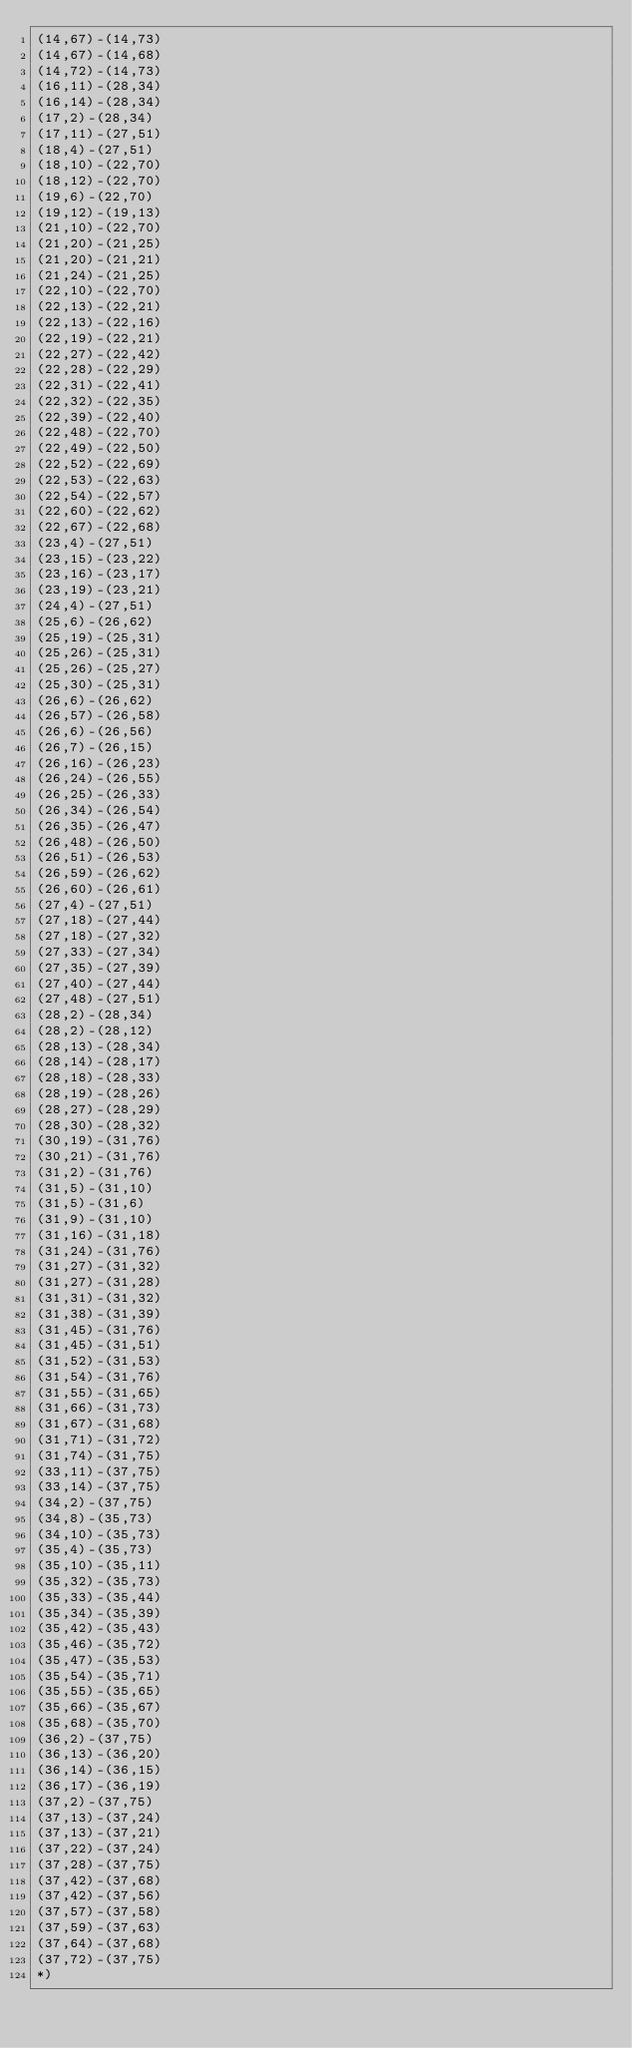<code> <loc_0><loc_0><loc_500><loc_500><_OCaml_>(14,67)-(14,73)
(14,67)-(14,68)
(14,72)-(14,73)
(16,11)-(28,34)
(16,14)-(28,34)
(17,2)-(28,34)
(17,11)-(27,51)
(18,4)-(27,51)
(18,10)-(22,70)
(18,12)-(22,70)
(19,6)-(22,70)
(19,12)-(19,13)
(21,10)-(22,70)
(21,20)-(21,25)
(21,20)-(21,21)
(21,24)-(21,25)
(22,10)-(22,70)
(22,13)-(22,21)
(22,13)-(22,16)
(22,19)-(22,21)
(22,27)-(22,42)
(22,28)-(22,29)
(22,31)-(22,41)
(22,32)-(22,35)
(22,39)-(22,40)
(22,48)-(22,70)
(22,49)-(22,50)
(22,52)-(22,69)
(22,53)-(22,63)
(22,54)-(22,57)
(22,60)-(22,62)
(22,67)-(22,68)
(23,4)-(27,51)
(23,15)-(23,22)
(23,16)-(23,17)
(23,19)-(23,21)
(24,4)-(27,51)
(25,6)-(26,62)
(25,19)-(25,31)
(25,26)-(25,31)
(25,26)-(25,27)
(25,30)-(25,31)
(26,6)-(26,62)
(26,57)-(26,58)
(26,6)-(26,56)
(26,7)-(26,15)
(26,16)-(26,23)
(26,24)-(26,55)
(26,25)-(26,33)
(26,34)-(26,54)
(26,35)-(26,47)
(26,48)-(26,50)
(26,51)-(26,53)
(26,59)-(26,62)
(26,60)-(26,61)
(27,4)-(27,51)
(27,18)-(27,44)
(27,18)-(27,32)
(27,33)-(27,34)
(27,35)-(27,39)
(27,40)-(27,44)
(27,48)-(27,51)
(28,2)-(28,34)
(28,2)-(28,12)
(28,13)-(28,34)
(28,14)-(28,17)
(28,18)-(28,33)
(28,19)-(28,26)
(28,27)-(28,29)
(28,30)-(28,32)
(30,19)-(31,76)
(30,21)-(31,76)
(31,2)-(31,76)
(31,5)-(31,10)
(31,5)-(31,6)
(31,9)-(31,10)
(31,16)-(31,18)
(31,24)-(31,76)
(31,27)-(31,32)
(31,27)-(31,28)
(31,31)-(31,32)
(31,38)-(31,39)
(31,45)-(31,76)
(31,45)-(31,51)
(31,52)-(31,53)
(31,54)-(31,76)
(31,55)-(31,65)
(31,66)-(31,73)
(31,67)-(31,68)
(31,71)-(31,72)
(31,74)-(31,75)
(33,11)-(37,75)
(33,14)-(37,75)
(34,2)-(37,75)
(34,8)-(35,73)
(34,10)-(35,73)
(35,4)-(35,73)
(35,10)-(35,11)
(35,32)-(35,73)
(35,33)-(35,44)
(35,34)-(35,39)
(35,42)-(35,43)
(35,46)-(35,72)
(35,47)-(35,53)
(35,54)-(35,71)
(35,55)-(35,65)
(35,66)-(35,67)
(35,68)-(35,70)
(36,2)-(37,75)
(36,13)-(36,20)
(36,14)-(36,15)
(36,17)-(36,19)
(37,2)-(37,75)
(37,13)-(37,24)
(37,13)-(37,21)
(37,22)-(37,24)
(37,28)-(37,75)
(37,42)-(37,68)
(37,42)-(37,56)
(37,57)-(37,58)
(37,59)-(37,63)
(37,64)-(37,68)
(37,72)-(37,75)
*)
</code> 